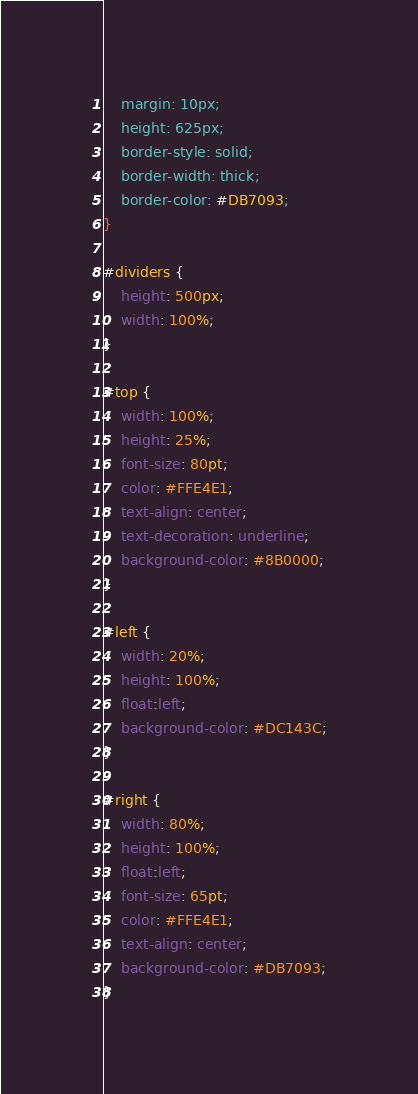<code> <loc_0><loc_0><loc_500><loc_500><_CSS_>	margin: 10px;
	height: 625px;
	border-style: solid;
	border-width: thick;
	border-color: #DB7093;
}

#dividers {
	height: 500px;
	width: 100%;
}

#top {
	width: 100%;
	height: 25%;
	font-size: 80pt;
	color: #FFE4E1;
	text-align: center;
	text-decoration: underline;
	background-color: #8B0000;
}

#left {
	width: 20%;
	height: 100%;
	float:left;
	background-color: #DC143C;
}

#right {
	width: 80%;
	height: 100%;
	float:left;
	font-size: 65pt;
	color: #FFE4E1;
	text-align: center;
	background-color: #DB7093;
}
</code> 